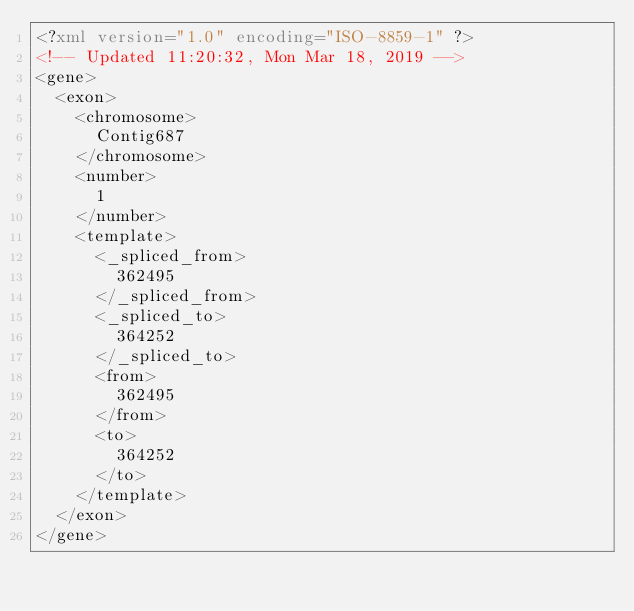<code> <loc_0><loc_0><loc_500><loc_500><_XML_><?xml version="1.0" encoding="ISO-8859-1" ?>
<!-- Updated 11:20:32, Mon Mar 18, 2019 -->
<gene>
	<exon>
		<chromosome>
			Contig687
		</chromosome>
		<number>
			1
		</number>
		<template>
			<_spliced_from>
				362495
			</_spliced_from>
			<_spliced_to>
				364252
			</_spliced_to>
			<from>
				362495
			</from>
			<to>
				364252
			</to>
		</template>
	</exon>
</gene>
</code> 